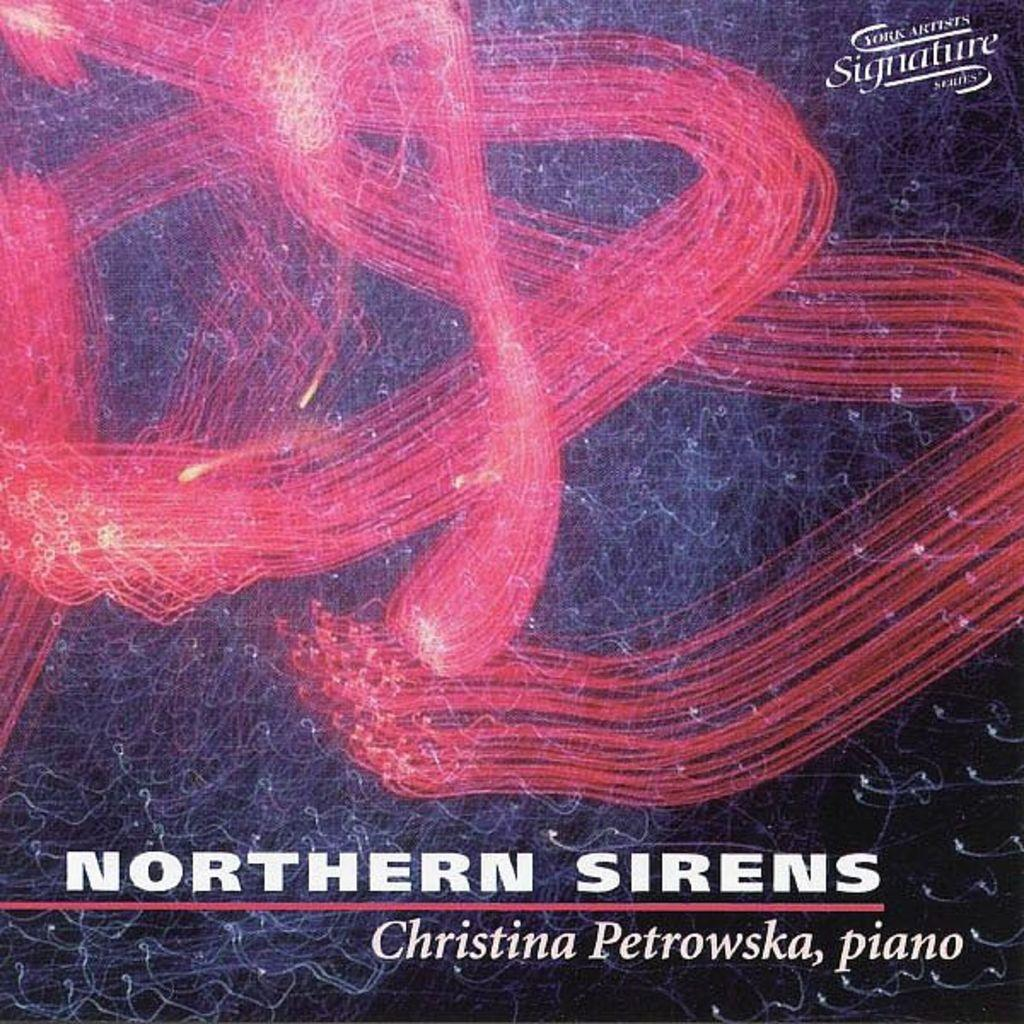<image>
Write a terse but informative summary of the picture. A book of music by Christina Petrowska on the piano 